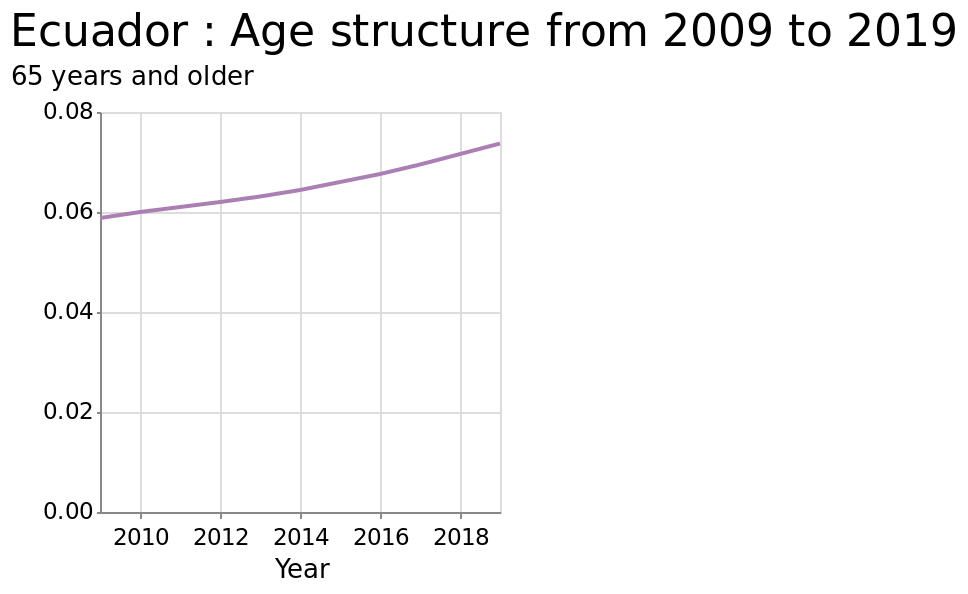<image>
What is the range of the y-axis in the line diagram?  The range of the y-axis in the line diagram is from 0.00 to 0.08. What has happened to the average age over the past 10 years?  The average age has increased over the past 10 years. What is the minimum and maximum value on the x-axis?  The minimum value on the x-axis is 2010 and the maximum value is 2018. How would you describe the population trend based on the given information?  The population is aging. What is the unit of measurement for the y-axis in the line diagram?  The unit of measurement for the y-axis in the line diagram is 65 years and older. What does the line diagram show for Ecuador from 2009 to 2019?  The line diagram shows the age structure of Ecuador from 2009 to 2019. 